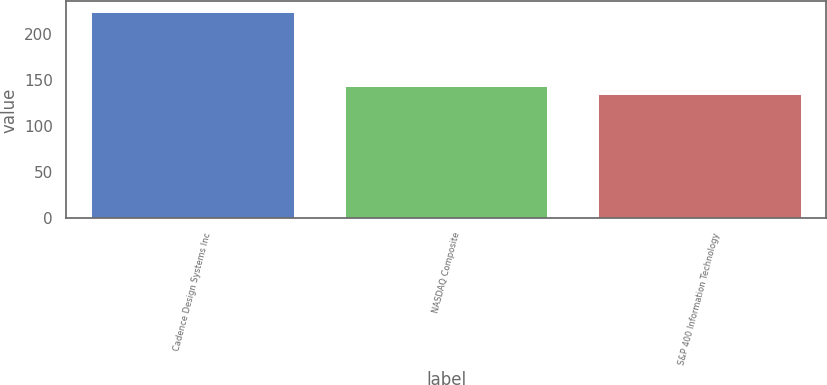Convert chart. <chart><loc_0><loc_0><loc_500><loc_500><bar_chart><fcel>Cadence Design Systems Inc<fcel>NASDAQ Composite<fcel>S&P 400 Information Technology<nl><fcel>224.37<fcel>144.2<fcel>135.29<nl></chart> 